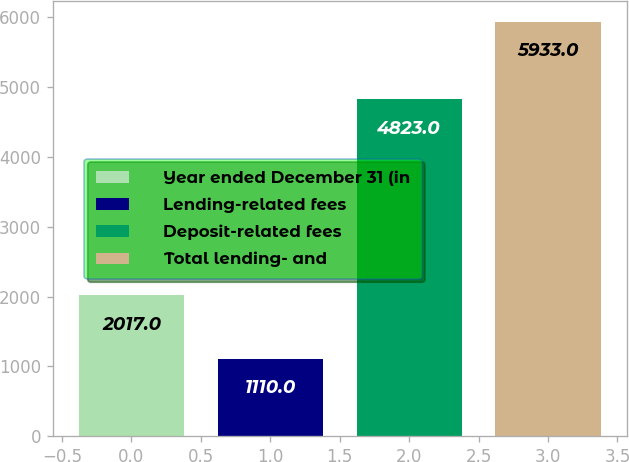<chart> <loc_0><loc_0><loc_500><loc_500><bar_chart><fcel>Year ended December 31 (in<fcel>Lending-related fees<fcel>Deposit-related fees<fcel>Total lending- and<nl><fcel>2017<fcel>1110<fcel>4823<fcel>5933<nl></chart> 